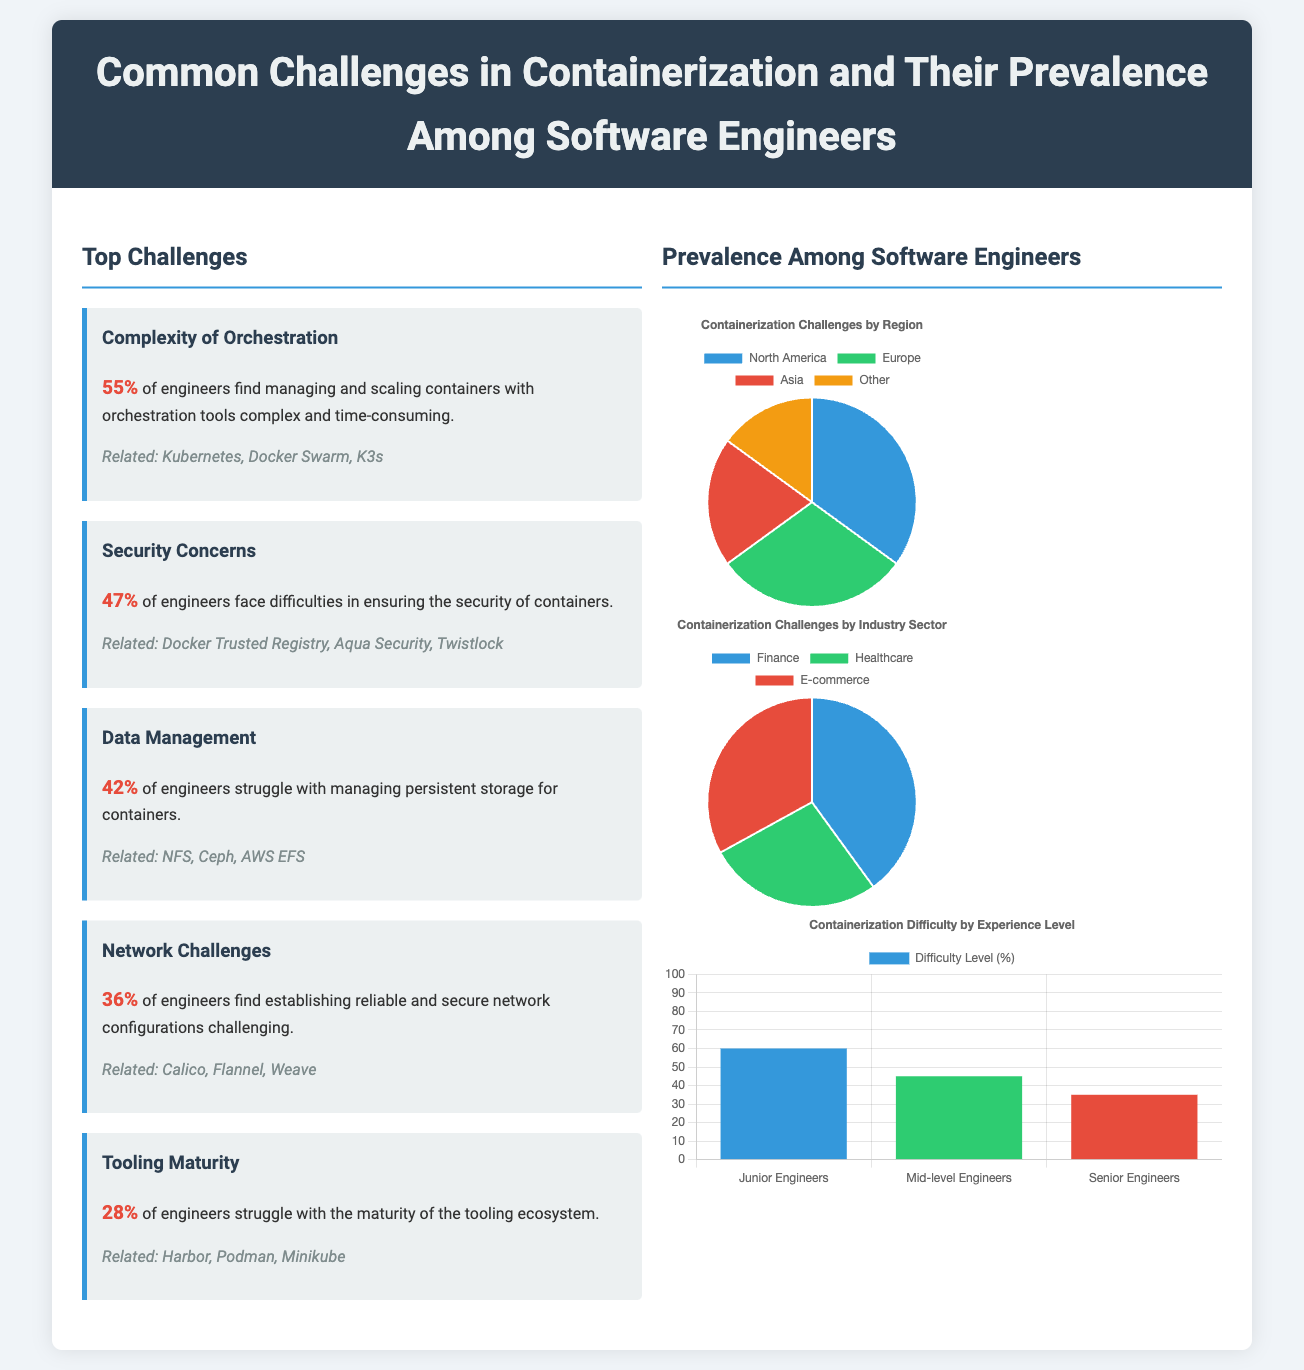What percentage of engineers find orchestration complex? The document states that 55% of engineers find managing and scaling containers with orchestration tools complex and time-consuming.
Answer: 55% What is the second most common challenge mentioned? The challenges are listed in order of prevalence, with security concerns being the second listed at 47%.
Answer: Security Concerns What percentage of engineers struggle with data management? The specific percentage of engineers that struggle with managing persistent storage for containers is provided as 42%.
Answer: 42% Which region has the highest prevalence of containerization challenges? The chart data indicates that North America has the highest percentage, at 35%.
Answer: North America What is the difficulty percentage for junior engineers? The infographic displays that junior engineers have a difficulty level percentage of 60%.
Answer: 60% What related technology is associated with security concerns? The infographic notes several related technologies, including Docker Trusted Registry.
Answer: Docker Trusted Registry What sector has the highest percentage facing containerization challenges? The document shows that the finance sector faces the highest percentage of challenges at 40%.
Answer: Finance How many challenges are listed in the top challenges section? The document provides a list of five challenges in the top challenges section.
Answer: Five What type of chart represents containerization challenges by experience level? The experience level data is represented using a bar chart.
Answer: Bar Chart 